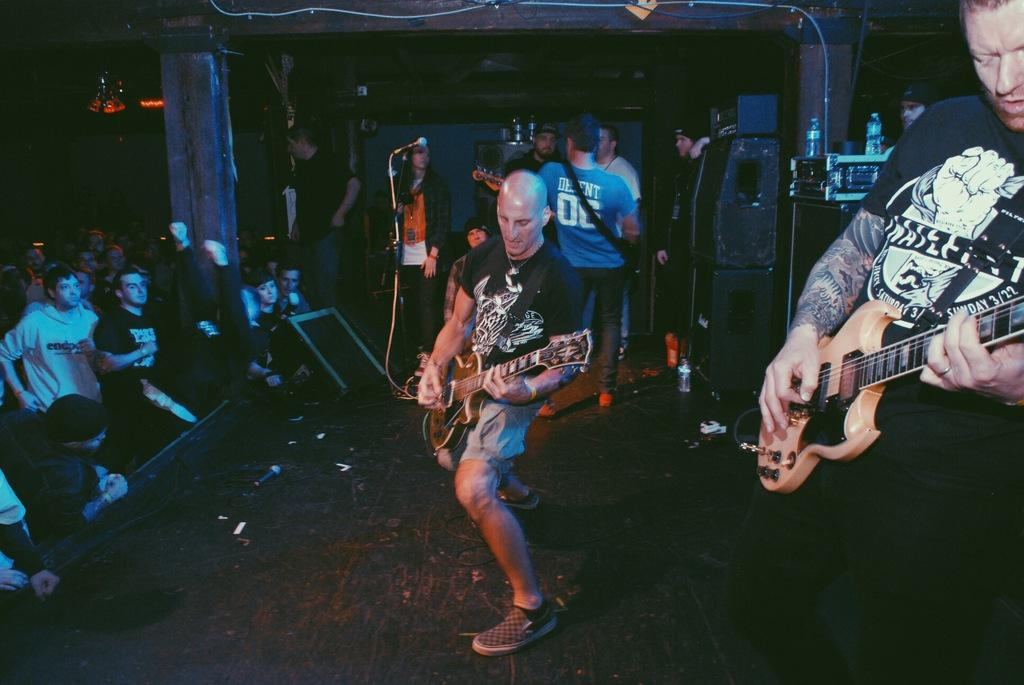How many people are in the image? There is a group of people in the image. What are the people doing in the image? The people are standing, and some of them are playing musical instruments on a stage. What can be seen in the background of the image? There are lights and a wall visible in the background of the image. What type of offer is being made by the person holding a notebook in the image? There is no person holding a notebook in the image, and therefore no offer can be observed. 